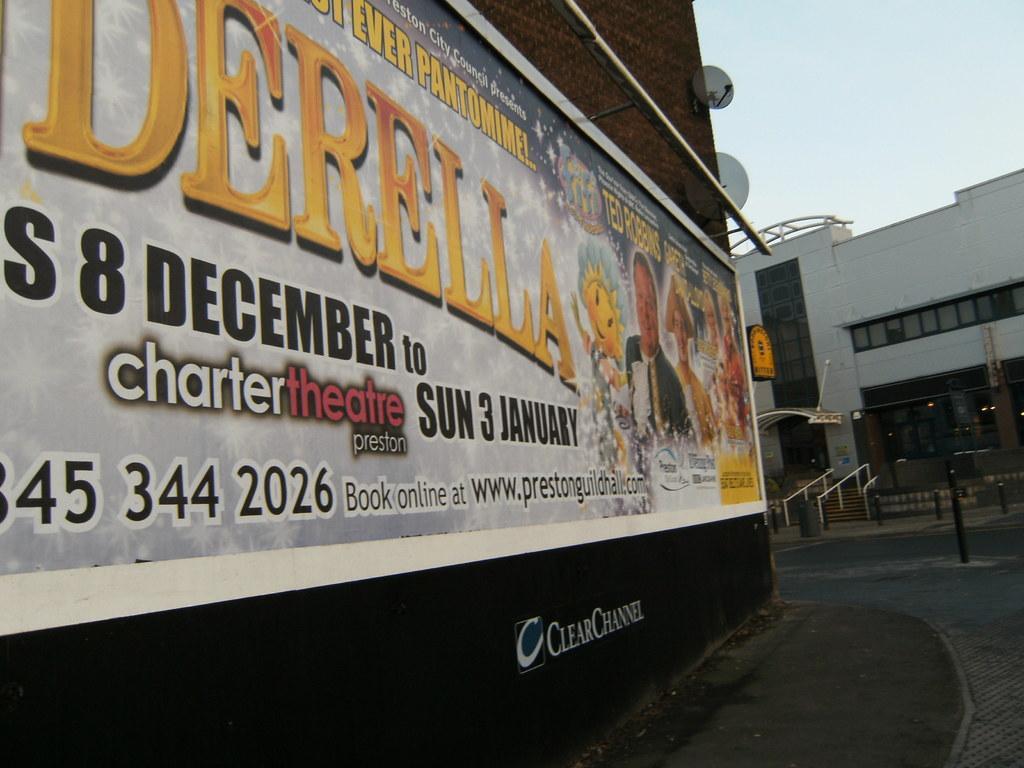How would you summarize this image in a sentence or two? This image consists of a board on which we can see a banner along with a text. On the right, there is a building. At the top, there is sky. 